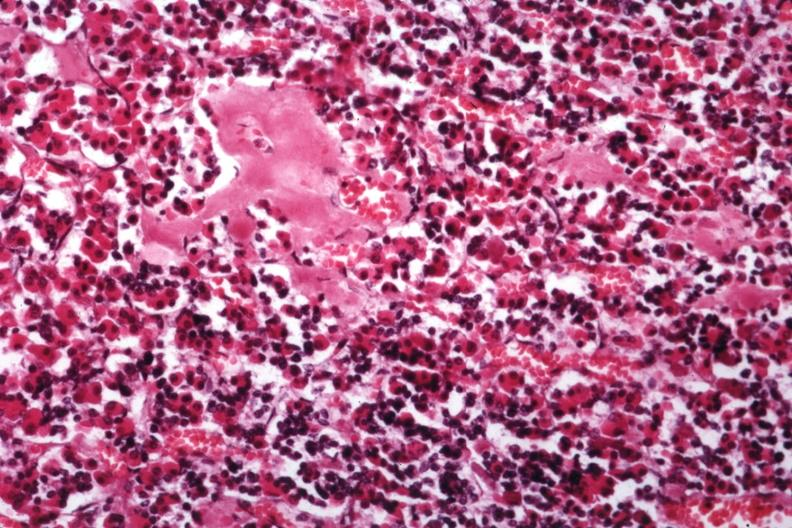where is this part in the figure?
Answer the question using a single word or phrase. Endocrine system 